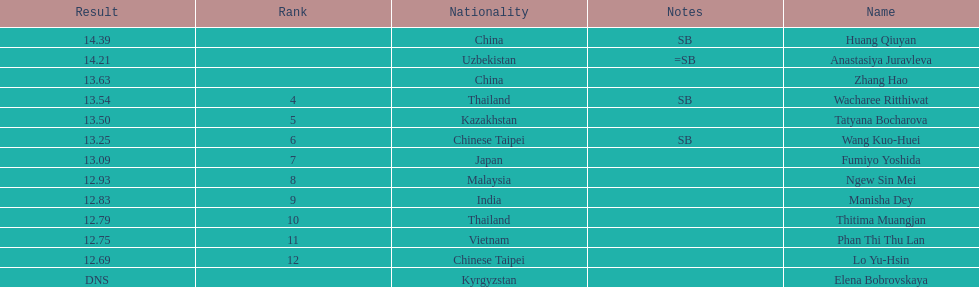Among the top 5 athletes, how many various nationalities are there? 4. 